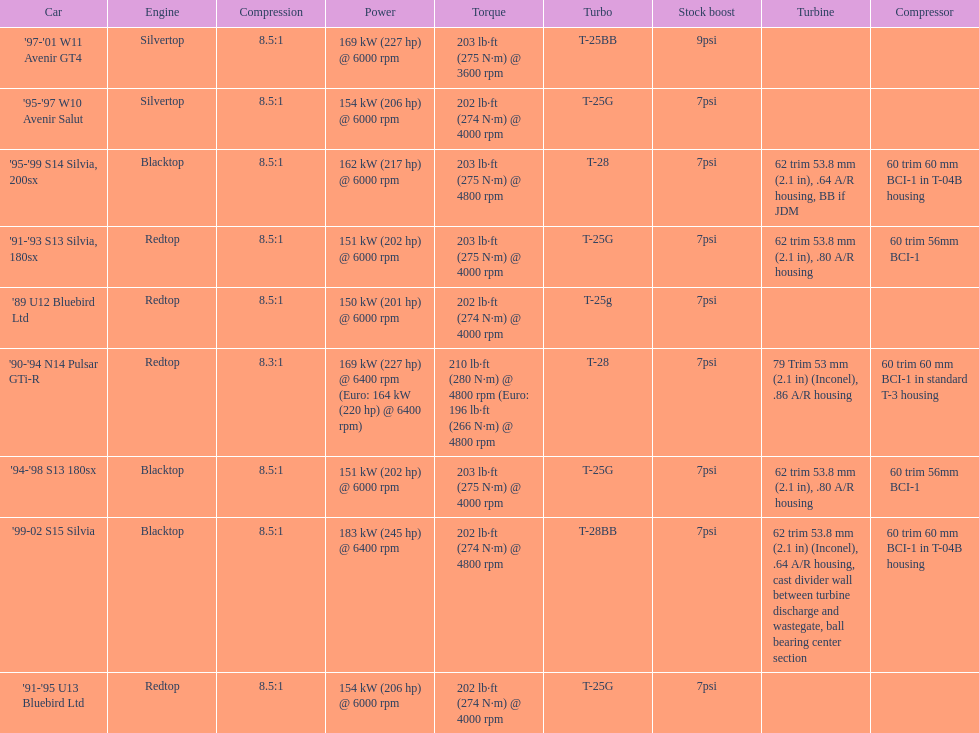Which cars list turbine details? '90-'94 N14 Pulsar GTi-R, '91-'93 S13 Silvia, 180sx, '94-'98 S13 180sx, '95-'99 S14 Silvia, 200sx, '99-02 S15 Silvia. Which of these hit their peak hp at the highest rpm? '90-'94 N14 Pulsar GTi-R, '99-02 S15 Silvia. Of those what is the compression of the only engine that isn't blacktop?? 8.3:1. 